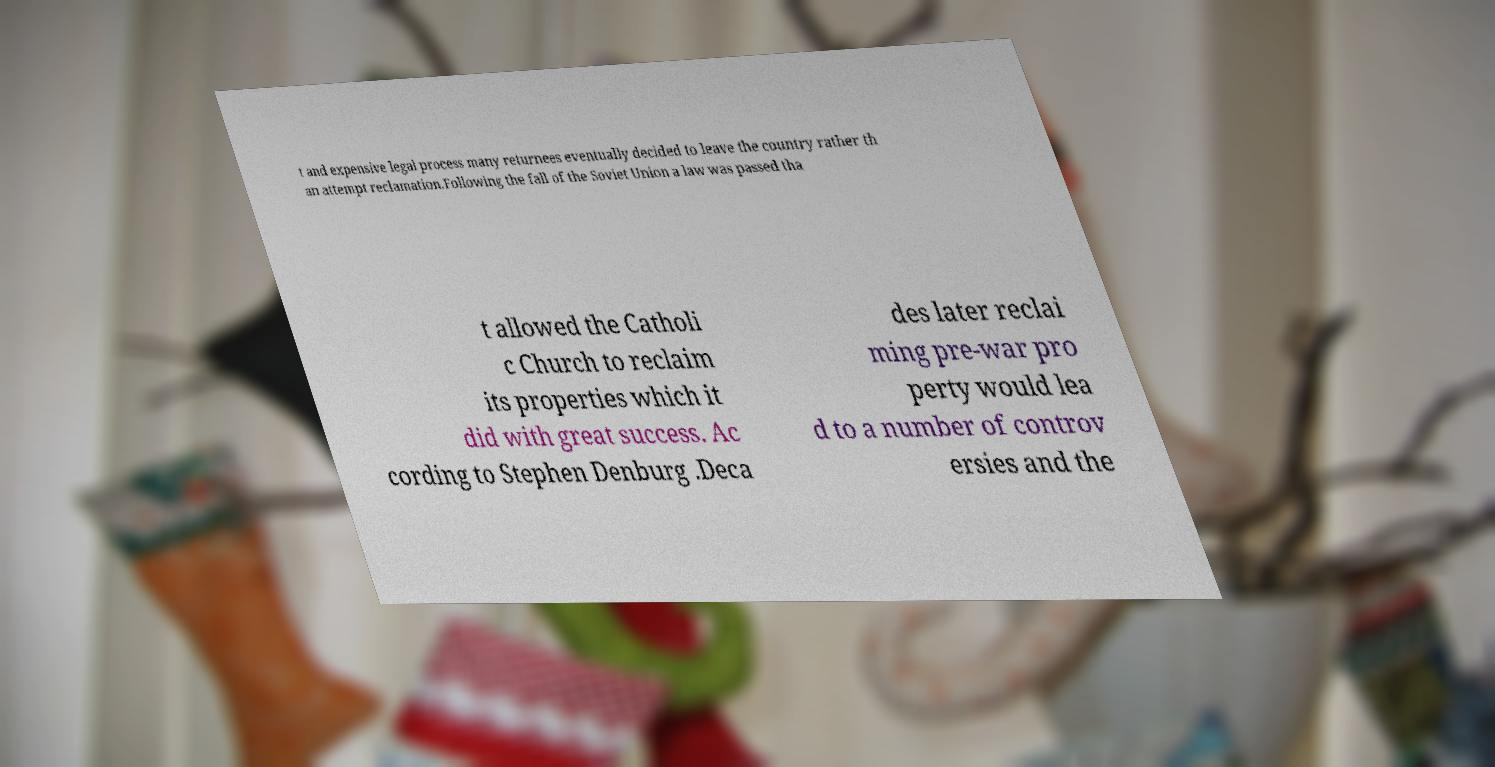I need the written content from this picture converted into text. Can you do that? t and expensive legal process many returnees eventually decided to leave the country rather th an attempt reclamation.Following the fall of the Soviet Union a law was passed tha t allowed the Catholi c Church to reclaim its properties which it did with great success. Ac cording to Stephen Denburg .Deca des later reclai ming pre-war pro perty would lea d to a number of controv ersies and the 